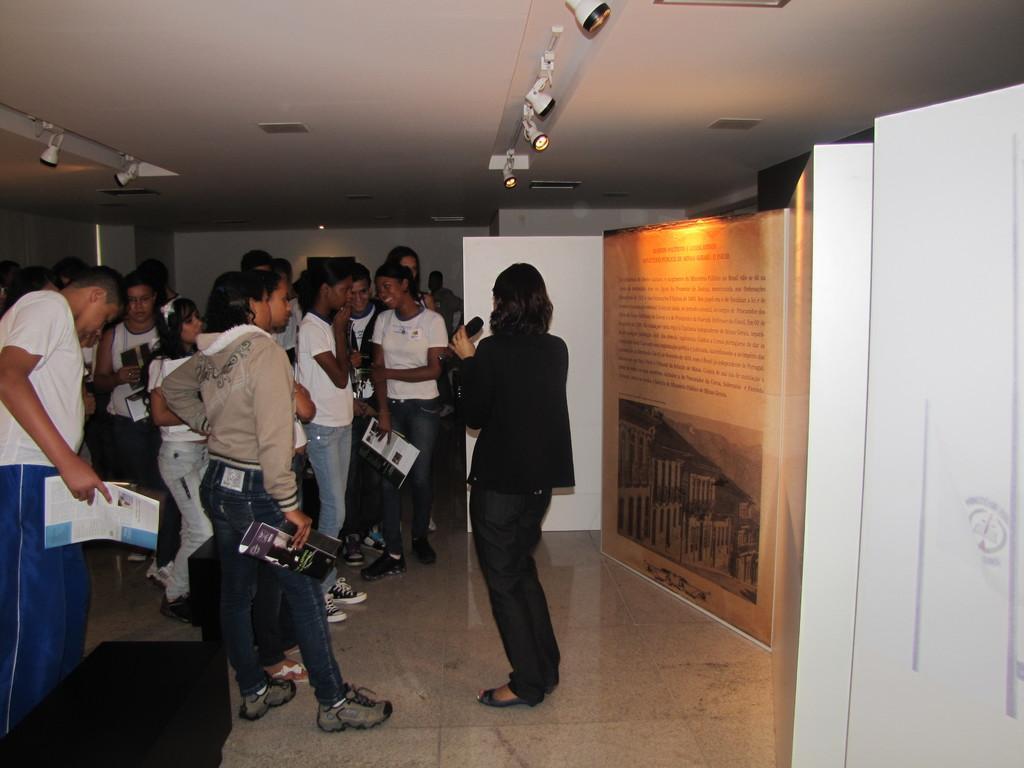Can you describe this image briefly? In this image on the left side I can see a group of people. At the top I can see the lights. 